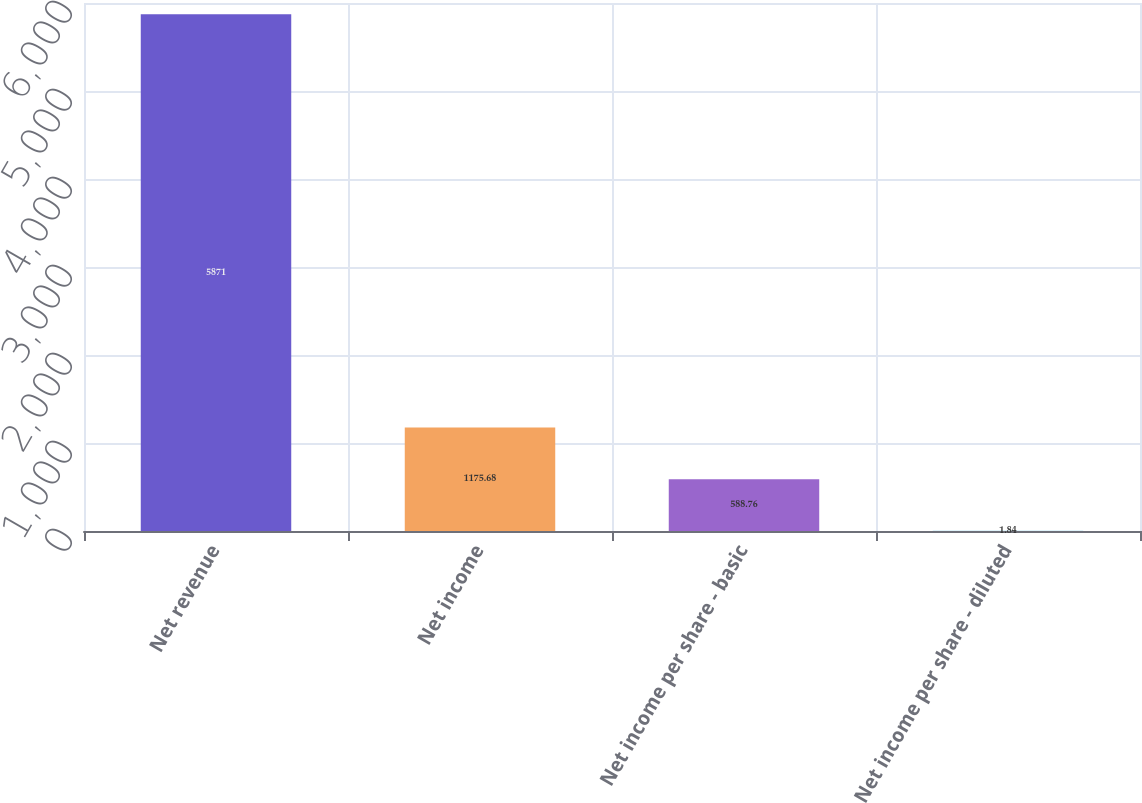Convert chart to OTSL. <chart><loc_0><loc_0><loc_500><loc_500><bar_chart><fcel>Net revenue<fcel>Net income<fcel>Net income per share - basic<fcel>Net income per share - diluted<nl><fcel>5871<fcel>1175.68<fcel>588.76<fcel>1.84<nl></chart> 